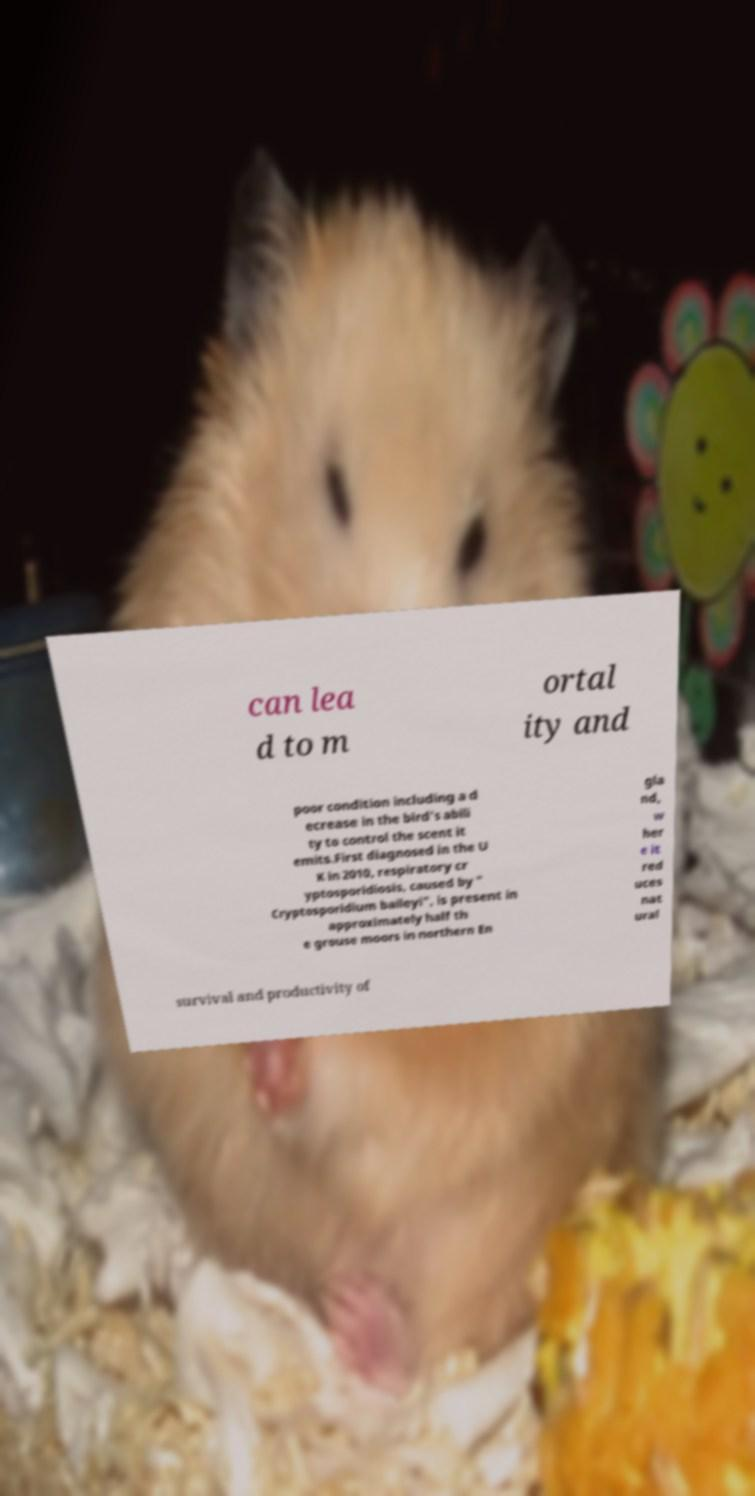I need the written content from this picture converted into text. Can you do that? can lea d to m ortal ity and poor condition including a d ecrease in the bird's abili ty to control the scent it emits.First diagnosed in the U K in 2010, respiratory cr yptosporidiosis, caused by " Cryptosporidium baileyi", is present in approximately half th e grouse moors in northern En gla nd, w her e it red uces nat ural survival and productivity of 